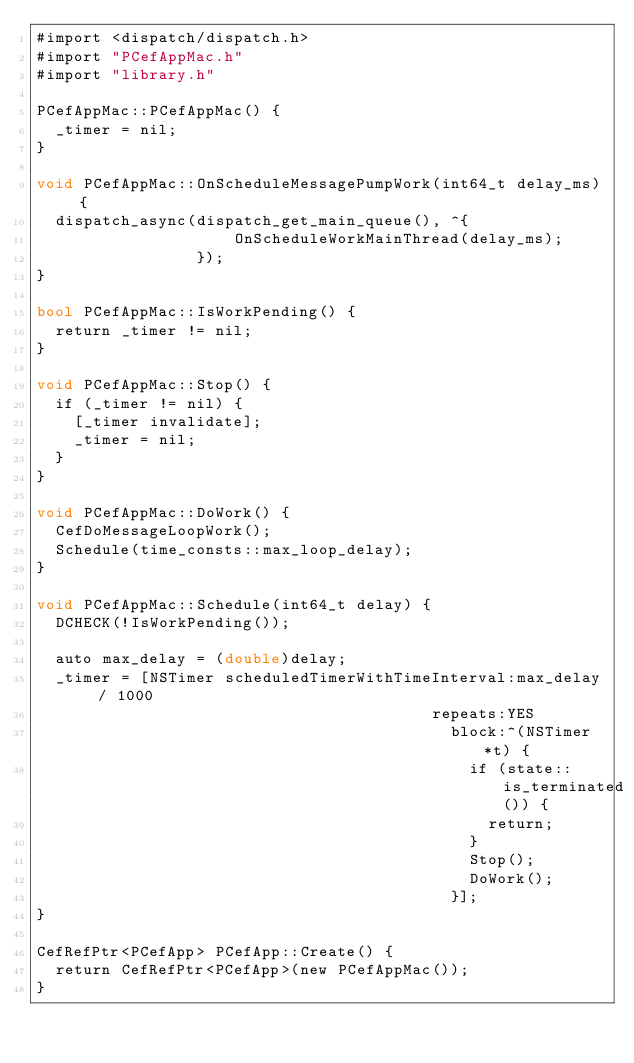<code> <loc_0><loc_0><loc_500><loc_500><_ObjectiveC_>#import <dispatch/dispatch.h>
#import "PCefAppMac.h"
#import "library.h"

PCefAppMac::PCefAppMac() {
  _timer = nil;
}

void PCefAppMac::OnScheduleMessagePumpWork(int64_t delay_ms) {
  dispatch_async(dispatch_get_main_queue(), ^{
                     OnScheduleWorkMainThread(delay_ms);
                 });
}

bool PCefAppMac::IsWorkPending() {
  return _timer != nil;
}

void PCefAppMac::Stop() {
  if (_timer != nil) {
    [_timer invalidate];
    _timer = nil;
  }
}

void PCefAppMac::DoWork() {
  CefDoMessageLoopWork();
  Schedule(time_consts::max_loop_delay);
}

void PCefAppMac::Schedule(int64_t delay) {
  DCHECK(!IsWorkPending());

  auto max_delay = (double)delay;
  _timer = [NSTimer scheduledTimerWithTimeInterval:max_delay / 1000
                                          repeats:YES
                                            block:^(NSTimer *t) {
                                              if (state::is_terminated()) {
                                                return;
                                              }
                                              Stop();
                                              DoWork();
                                            }];
}

CefRefPtr<PCefApp> PCefApp::Create() {
  return CefRefPtr<PCefApp>(new PCefAppMac());
}
</code> 